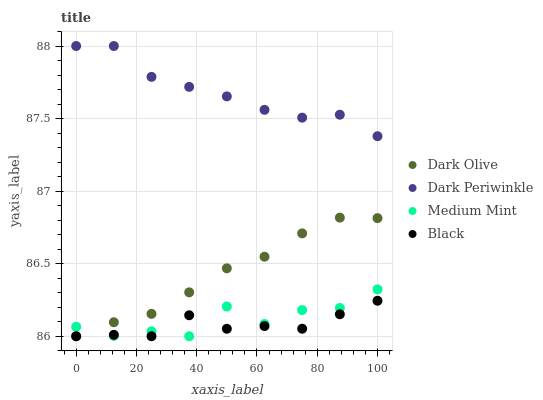Does Black have the minimum area under the curve?
Answer yes or no. Yes. Does Dark Periwinkle have the maximum area under the curve?
Answer yes or no. Yes. Does Dark Olive have the minimum area under the curve?
Answer yes or no. No. Does Dark Olive have the maximum area under the curve?
Answer yes or no. No. Is Dark Olive the smoothest?
Answer yes or no. Yes. Is Medium Mint the roughest?
Answer yes or no. Yes. Is Black the smoothest?
Answer yes or no. No. Is Black the roughest?
Answer yes or no. No. Does Medium Mint have the lowest value?
Answer yes or no. Yes. Does Dark Periwinkle have the lowest value?
Answer yes or no. No. Does Dark Periwinkle have the highest value?
Answer yes or no. Yes. Does Dark Olive have the highest value?
Answer yes or no. No. Is Dark Olive less than Dark Periwinkle?
Answer yes or no. Yes. Is Dark Periwinkle greater than Medium Mint?
Answer yes or no. Yes. Does Medium Mint intersect Dark Olive?
Answer yes or no. Yes. Is Medium Mint less than Dark Olive?
Answer yes or no. No. Is Medium Mint greater than Dark Olive?
Answer yes or no. No. Does Dark Olive intersect Dark Periwinkle?
Answer yes or no. No. 